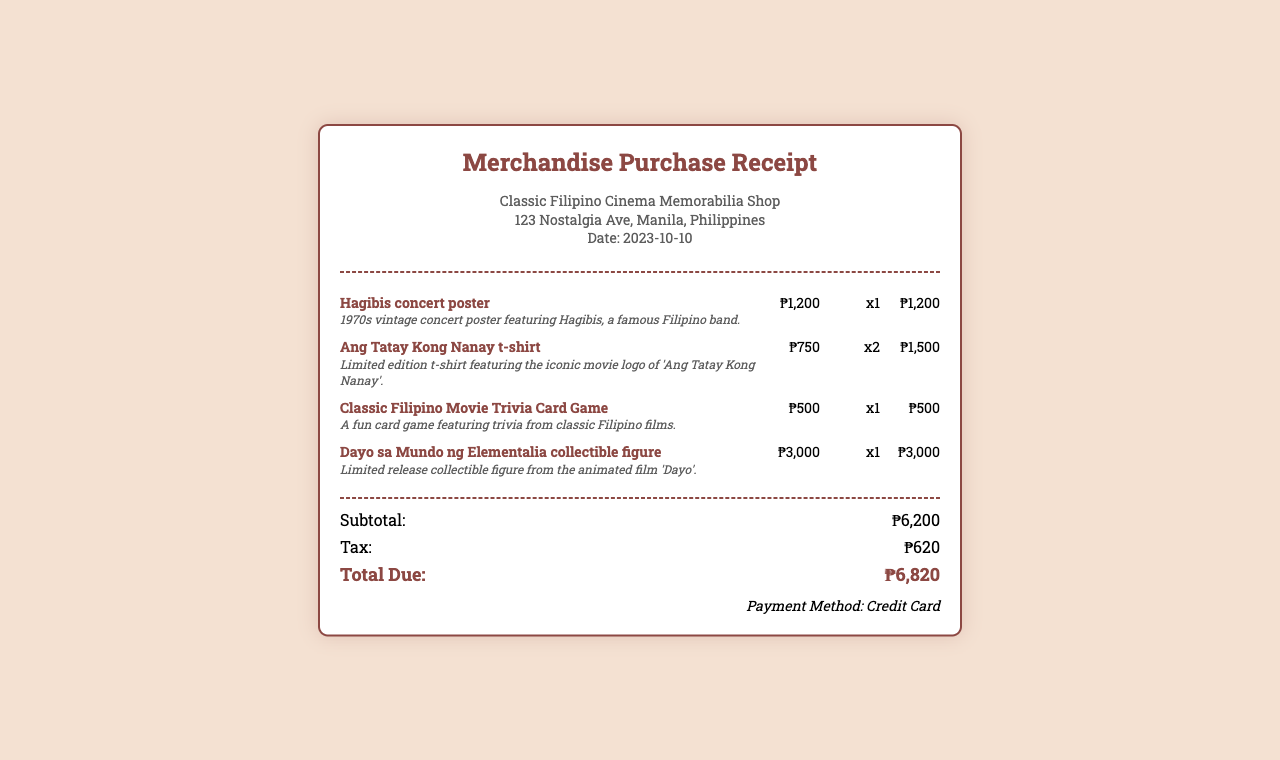What is the date of purchase? The date of purchase is listed in the receipt under the store information section.
Answer: 2023-10-10 What is the name of the first item purchased? The first item listed in the items section of the receipt is identified by its name.
Answer: Hagibis concert poster How much did the Ang Tatay Kong Nanay t-shirt cost? The cost of the t-shirt can be found next to its name in the items section of the receipt.
Answer: ₱750 What is the subtotal of the purchase? The subtotal is the sum of all item prices before tax, shown in the totals section of the receipt.
Answer: ₱6,200 How many Classic Filipino Movie Trivia Card Games were purchased? The quantity of this item is stated next to its name in the items section of the receipt.
Answer: x1 What is the total amount due after tax? The total due is displayed in the totals section at the bottom of the receipt.
Answer: ₱6,820 What payment method was used for the purchase? The payment method is indicated at the bottom of the receipt.
Answer: Credit Card What is the tax amount charged on the purchase? The tax amount is detailed in the totals section of the receipt.
Answer: ₱620 How much did the Dayo sa Mundo ng Elementalia collectible figure cost? The cost of this collectible figure can be found next to its name in the items section of the receipt.
Answer: ₱3,000 